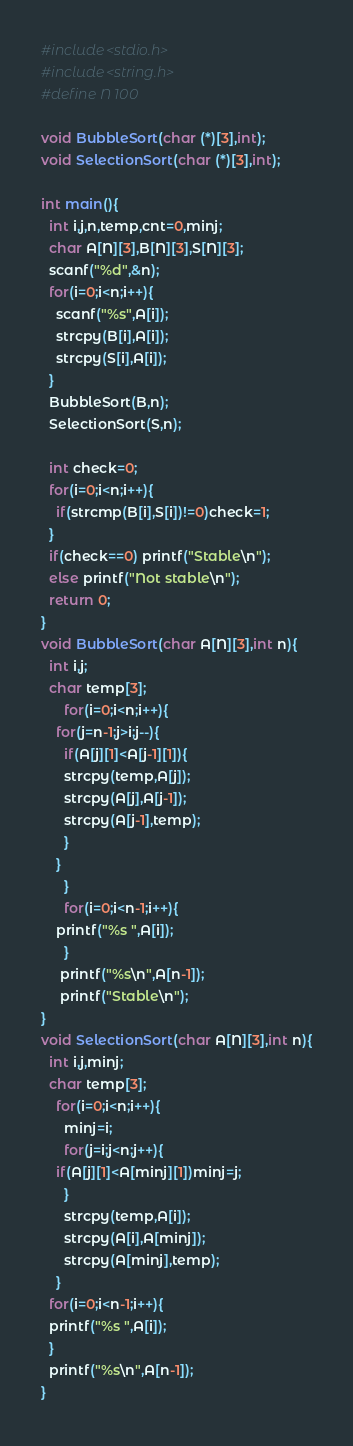Convert code to text. <code><loc_0><loc_0><loc_500><loc_500><_C_>#include<stdio.h>
#include<string.h>
#define N 100

void BubbleSort(char (*)[3],int);
void SelectionSort(char (*)[3],int);

int main(){
  int i,j,n,temp,cnt=0,minj;
  char A[N][3],B[N][3],S[N][3];
  scanf("%d",&n);
  for(i=0;i<n;i++){
    scanf("%s",A[i]);
    strcpy(B[i],A[i]);
    strcpy(S[i],A[i]);
  }
  BubbleSort(B,n);
  SelectionSort(S,n);

  int check=0;
  for(i=0;i<n;i++){
    if(strcmp(B[i],S[i])!=0)check=1;
  }
  if(check==0) printf("Stable\n");
  else printf("Not stable\n");
  return 0;
}
void BubbleSort(char A[N][3],int n){
  int i,j;
  char temp[3];
      for(i=0;i<n;i++){
	for(j=n-1;j>i;j--){
	  if(A[j][1]<A[j-1][1]){
	  strcpy(temp,A[j]);
	  strcpy(A[j],A[j-1]);
	  strcpy(A[j-1],temp);
	  }
	}
      }
      for(i=0;i<n-1;i++){
	printf("%s ",A[i]);
      }
     printf("%s\n",A[n-1]);
     printf("Stable\n");
}
void SelectionSort(char A[N][3],int n){
  int i,j,minj;
  char temp[3];
    for(i=0;i<n;i++){
      minj=i;
      for(j=i;j<n;j++){
	if(A[j][1]<A[minj][1])minj=j;
      }
      strcpy(temp,A[i]);
      strcpy(A[i],A[minj]);
      strcpy(A[minj],temp);
    }
  for(i=0;i<n-1;i++){
  printf("%s ",A[i]);
  }
  printf("%s\n",A[n-1]);
}



</code> 